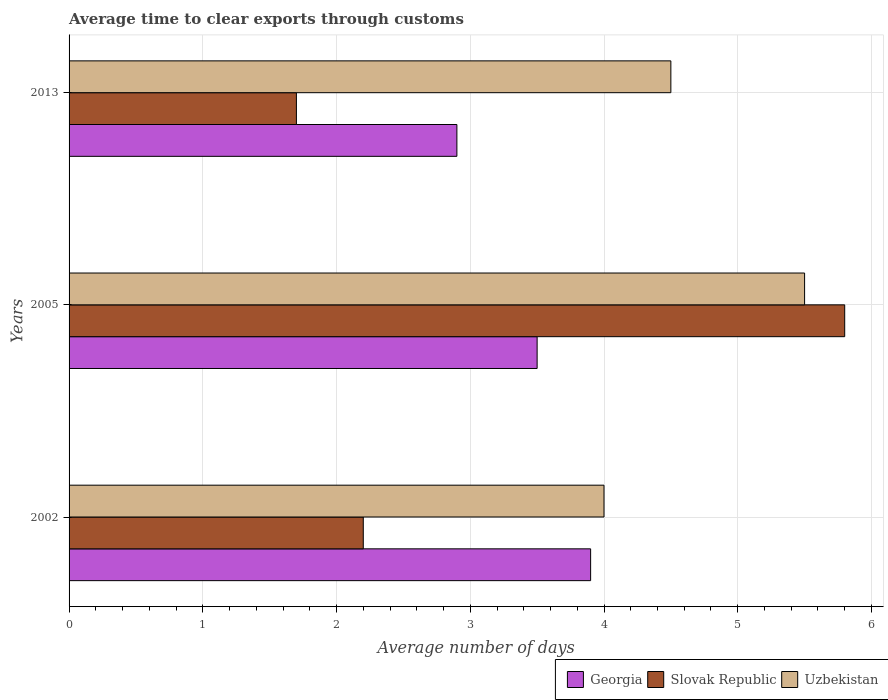How many different coloured bars are there?
Offer a very short reply. 3. How many groups of bars are there?
Keep it short and to the point. 3. Are the number of bars per tick equal to the number of legend labels?
Provide a succinct answer. Yes. How many bars are there on the 1st tick from the top?
Your answer should be compact. 3. How many bars are there on the 2nd tick from the bottom?
Provide a short and direct response. 3. What is the label of the 1st group of bars from the top?
Your answer should be very brief. 2013. What is the average number of days required to clear exports through customs in Uzbekistan in 2013?
Provide a short and direct response. 4.5. What is the total average number of days required to clear exports through customs in Slovak Republic in the graph?
Offer a terse response. 9.7. What is the difference between the average number of days required to clear exports through customs in Slovak Republic in 2005 and the average number of days required to clear exports through customs in Uzbekistan in 2002?
Your answer should be very brief. 1.8. What is the average average number of days required to clear exports through customs in Georgia per year?
Keep it short and to the point. 3.43. In the year 2005, what is the difference between the average number of days required to clear exports through customs in Slovak Republic and average number of days required to clear exports through customs in Uzbekistan?
Your answer should be very brief. 0.3. In how many years, is the average number of days required to clear exports through customs in Uzbekistan greater than 5.4 days?
Keep it short and to the point. 1. What is the ratio of the average number of days required to clear exports through customs in Slovak Republic in 2002 to that in 2005?
Offer a very short reply. 0.38. What is the difference between the highest and the second highest average number of days required to clear exports through customs in Georgia?
Give a very brief answer. 0.4. What is the difference between the highest and the lowest average number of days required to clear exports through customs in Uzbekistan?
Give a very brief answer. 1.5. In how many years, is the average number of days required to clear exports through customs in Uzbekistan greater than the average average number of days required to clear exports through customs in Uzbekistan taken over all years?
Make the answer very short. 1. Is the sum of the average number of days required to clear exports through customs in Slovak Republic in 2005 and 2013 greater than the maximum average number of days required to clear exports through customs in Georgia across all years?
Your response must be concise. Yes. What does the 3rd bar from the top in 2005 represents?
Your response must be concise. Georgia. What does the 3rd bar from the bottom in 2005 represents?
Offer a terse response. Uzbekistan. Are all the bars in the graph horizontal?
Your answer should be compact. Yes. How many years are there in the graph?
Your response must be concise. 3. What is the difference between two consecutive major ticks on the X-axis?
Offer a terse response. 1. Are the values on the major ticks of X-axis written in scientific E-notation?
Keep it short and to the point. No. Where does the legend appear in the graph?
Your response must be concise. Bottom right. How many legend labels are there?
Provide a succinct answer. 3. How are the legend labels stacked?
Make the answer very short. Horizontal. What is the title of the graph?
Your answer should be compact. Average time to clear exports through customs. Does "Colombia" appear as one of the legend labels in the graph?
Ensure brevity in your answer.  No. What is the label or title of the X-axis?
Give a very brief answer. Average number of days. What is the label or title of the Y-axis?
Your response must be concise. Years. What is the Average number of days in Georgia in 2002?
Your answer should be very brief. 3.9. What is the Average number of days in Uzbekistan in 2005?
Offer a terse response. 5.5. What is the Average number of days of Slovak Republic in 2013?
Offer a very short reply. 1.7. What is the Average number of days of Uzbekistan in 2013?
Offer a very short reply. 4.5. Across all years, what is the maximum Average number of days of Georgia?
Provide a succinct answer. 3.9. Across all years, what is the maximum Average number of days in Uzbekistan?
Your response must be concise. 5.5. Across all years, what is the minimum Average number of days in Slovak Republic?
Give a very brief answer. 1.7. What is the total Average number of days in Georgia in the graph?
Provide a short and direct response. 10.3. What is the total Average number of days of Uzbekistan in the graph?
Make the answer very short. 14. What is the difference between the Average number of days in Georgia in 2002 and that in 2005?
Provide a short and direct response. 0.4. What is the difference between the Average number of days of Slovak Republic in 2002 and that in 2005?
Give a very brief answer. -3.6. What is the difference between the Average number of days in Georgia in 2005 and that in 2013?
Give a very brief answer. 0.6. What is the difference between the Average number of days of Slovak Republic in 2005 and that in 2013?
Offer a terse response. 4.1. What is the difference between the Average number of days in Uzbekistan in 2005 and that in 2013?
Your response must be concise. 1. What is the difference between the Average number of days in Slovak Republic in 2005 and the Average number of days in Uzbekistan in 2013?
Keep it short and to the point. 1.3. What is the average Average number of days in Georgia per year?
Your answer should be compact. 3.43. What is the average Average number of days of Slovak Republic per year?
Provide a succinct answer. 3.23. What is the average Average number of days in Uzbekistan per year?
Your response must be concise. 4.67. In the year 2002, what is the difference between the Average number of days in Georgia and Average number of days in Slovak Republic?
Ensure brevity in your answer.  1.7. In the year 2002, what is the difference between the Average number of days in Georgia and Average number of days in Uzbekistan?
Your answer should be compact. -0.1. In the year 2002, what is the difference between the Average number of days in Slovak Republic and Average number of days in Uzbekistan?
Offer a terse response. -1.8. In the year 2013, what is the difference between the Average number of days of Georgia and Average number of days of Uzbekistan?
Ensure brevity in your answer.  -1.6. In the year 2013, what is the difference between the Average number of days of Slovak Republic and Average number of days of Uzbekistan?
Ensure brevity in your answer.  -2.8. What is the ratio of the Average number of days in Georgia in 2002 to that in 2005?
Provide a short and direct response. 1.11. What is the ratio of the Average number of days of Slovak Republic in 2002 to that in 2005?
Keep it short and to the point. 0.38. What is the ratio of the Average number of days in Uzbekistan in 2002 to that in 2005?
Provide a succinct answer. 0.73. What is the ratio of the Average number of days in Georgia in 2002 to that in 2013?
Your answer should be compact. 1.34. What is the ratio of the Average number of days of Slovak Republic in 2002 to that in 2013?
Provide a succinct answer. 1.29. What is the ratio of the Average number of days in Georgia in 2005 to that in 2013?
Your answer should be very brief. 1.21. What is the ratio of the Average number of days of Slovak Republic in 2005 to that in 2013?
Offer a very short reply. 3.41. What is the ratio of the Average number of days in Uzbekistan in 2005 to that in 2013?
Offer a very short reply. 1.22. What is the difference between the highest and the second highest Average number of days in Georgia?
Give a very brief answer. 0.4. What is the difference between the highest and the second highest Average number of days in Slovak Republic?
Your answer should be compact. 3.6. What is the difference between the highest and the second highest Average number of days in Uzbekistan?
Make the answer very short. 1. What is the difference between the highest and the lowest Average number of days in Georgia?
Offer a very short reply. 1. What is the difference between the highest and the lowest Average number of days of Uzbekistan?
Offer a terse response. 1.5. 